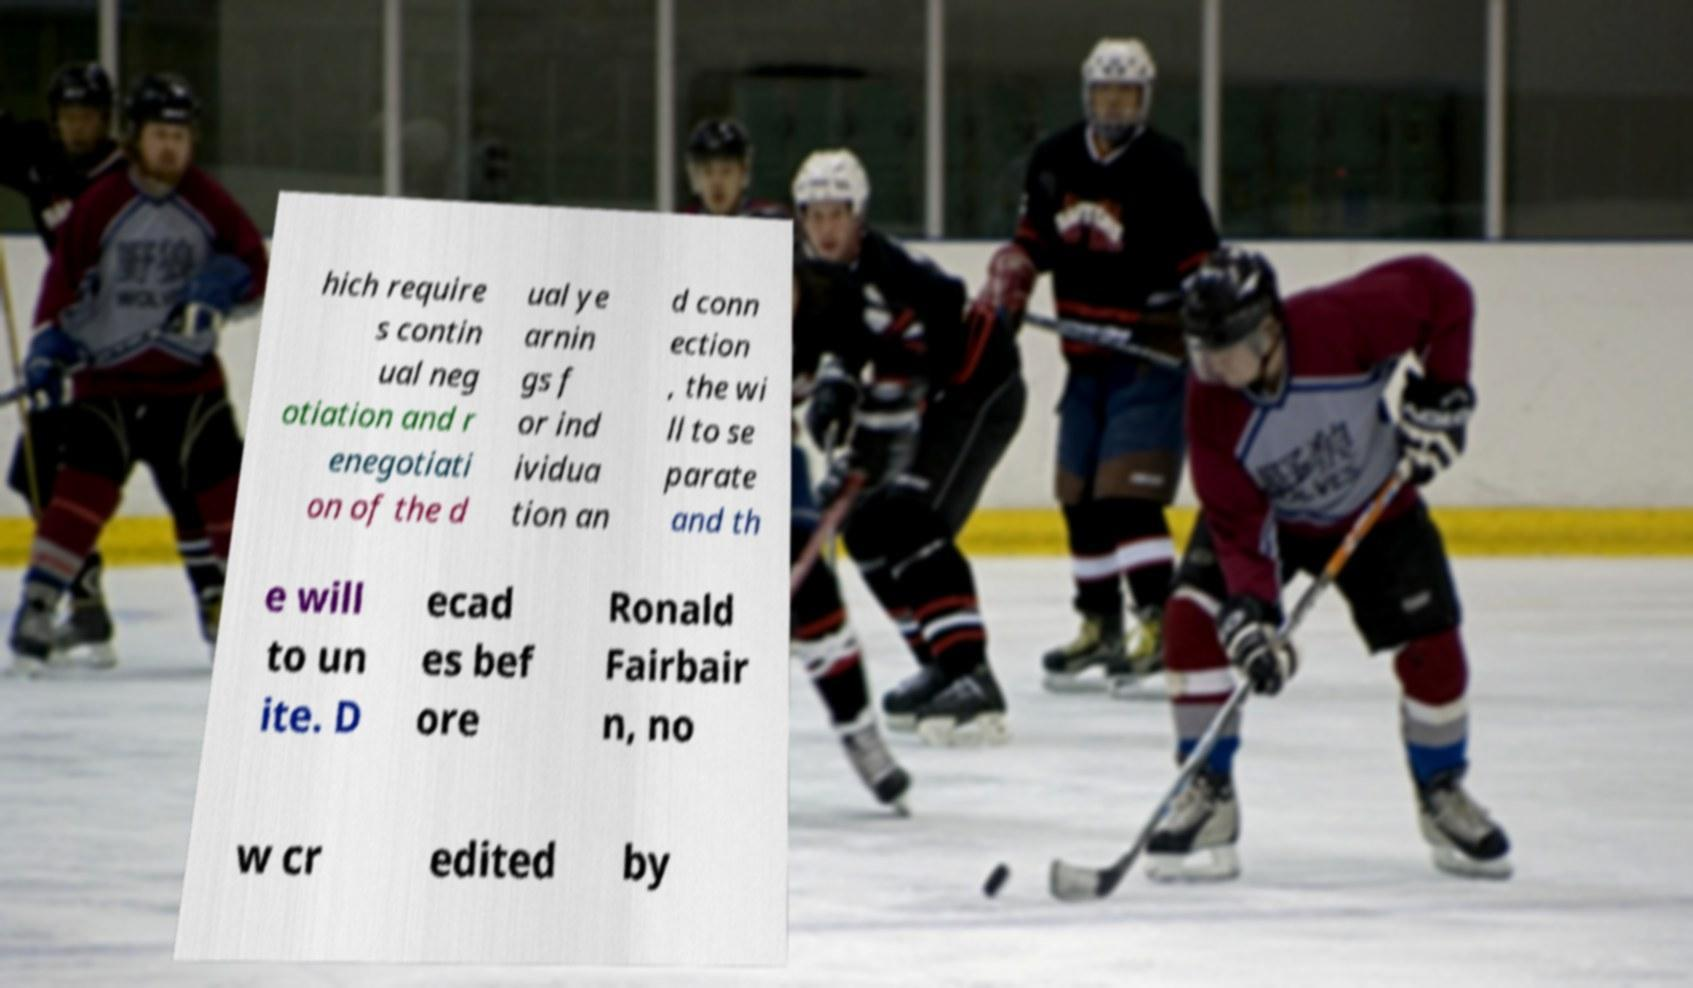Could you assist in decoding the text presented in this image and type it out clearly? hich require s contin ual neg otiation and r enegotiati on of the d ual ye arnin gs f or ind ividua tion an d conn ection , the wi ll to se parate and th e will to un ite. D ecad es bef ore Ronald Fairbair n, no w cr edited by 